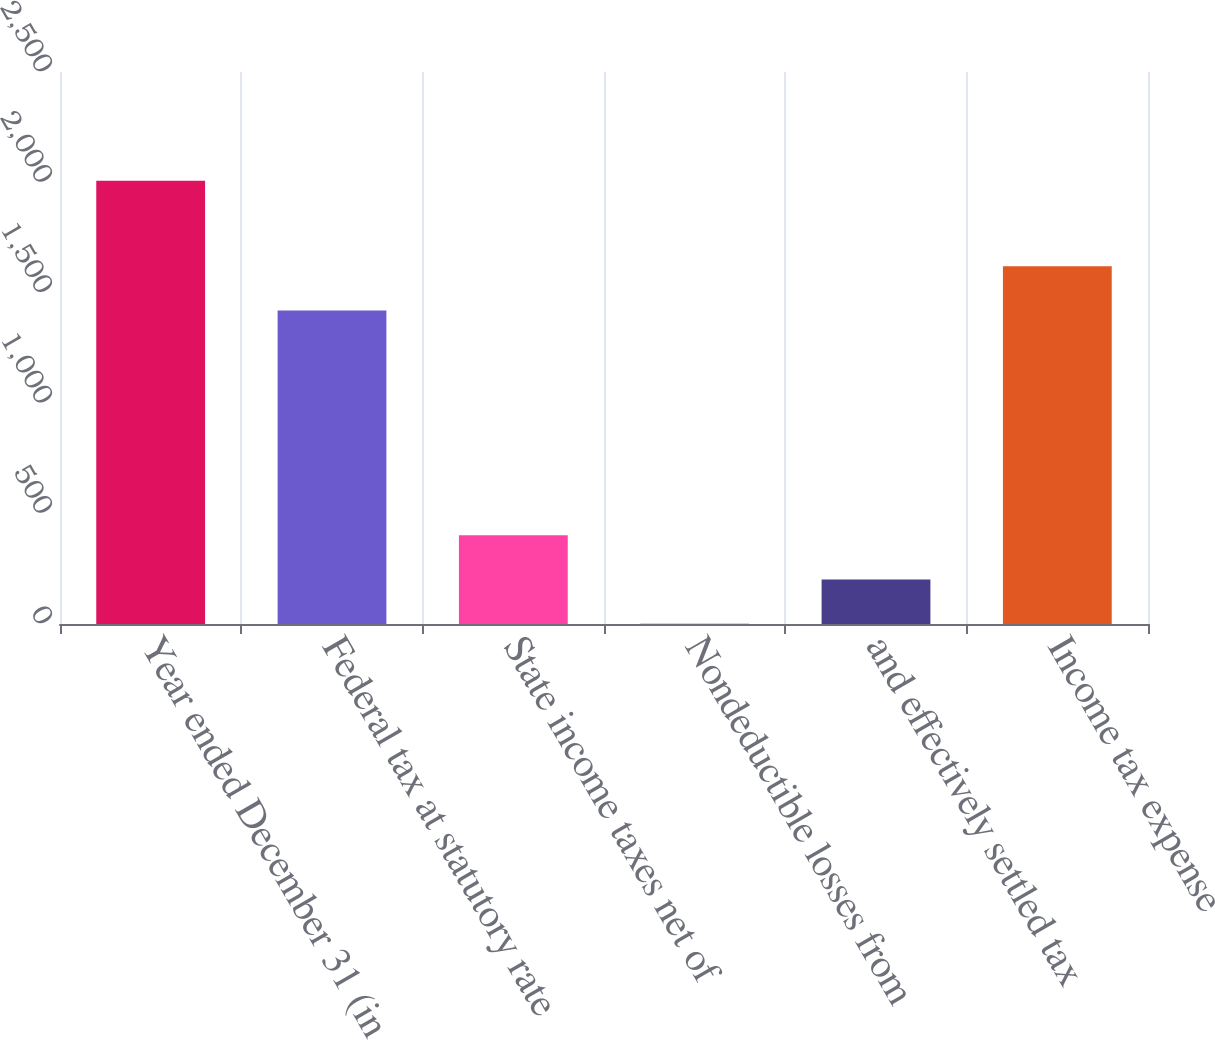Convert chart. <chart><loc_0><loc_0><loc_500><loc_500><bar_chart><fcel>Year ended December 31 (in<fcel>Federal tax at statutory rate<fcel>State income taxes net of<fcel>Nondeductible losses from<fcel>and effectively settled tax<fcel>Income tax expense<nl><fcel>2008<fcel>1420<fcel>402.4<fcel>1<fcel>201.7<fcel>1620.7<nl></chart> 